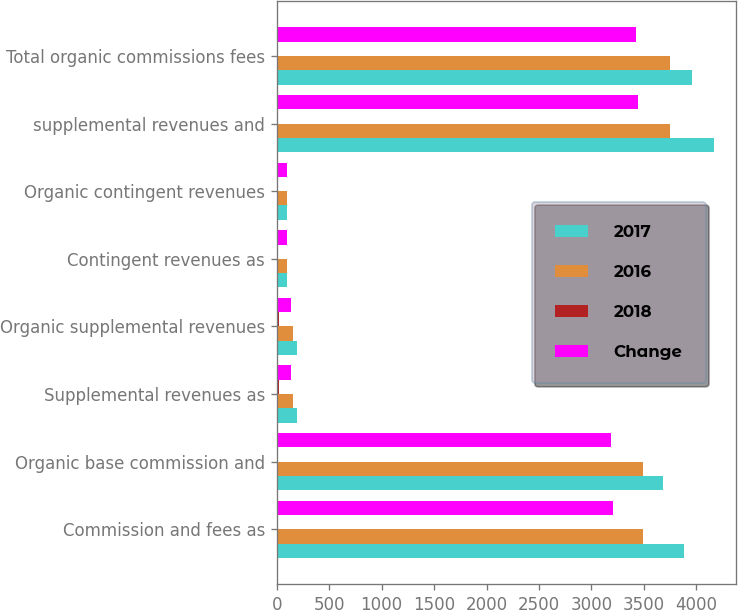Convert chart to OTSL. <chart><loc_0><loc_0><loc_500><loc_500><stacked_bar_chart><ecel><fcel>Commission and fees as<fcel>Organic base commission and<fcel>Supplemental revenues as<fcel>Organic supplemental revenues<fcel>Contingent revenues as<fcel>Organic contingent revenues<fcel>supplemental revenues and<fcel>Total organic commissions fees<nl><fcel>2017<fcel>3879.2<fcel>3678.8<fcel>189.9<fcel>188.4<fcel>98<fcel>93<fcel>4167.1<fcel>3960.2<nl><fcel>2016<fcel>3496.1<fcel>3491.2<fcel>158<fcel>158.8<fcel>99.5<fcel>99<fcel>3753.6<fcel>3749<nl><fcel>2018<fcel>11<fcel>5.4<fcel>20.2<fcel>18.6<fcel>1.5<fcel>6.1<fcel>11<fcel>5.6<nl><fcel>Change<fcel>3204.6<fcel>3191.2<fcel>139.9<fcel>139<fcel>97.9<fcel>97.7<fcel>3442.4<fcel>3427.9<nl></chart> 